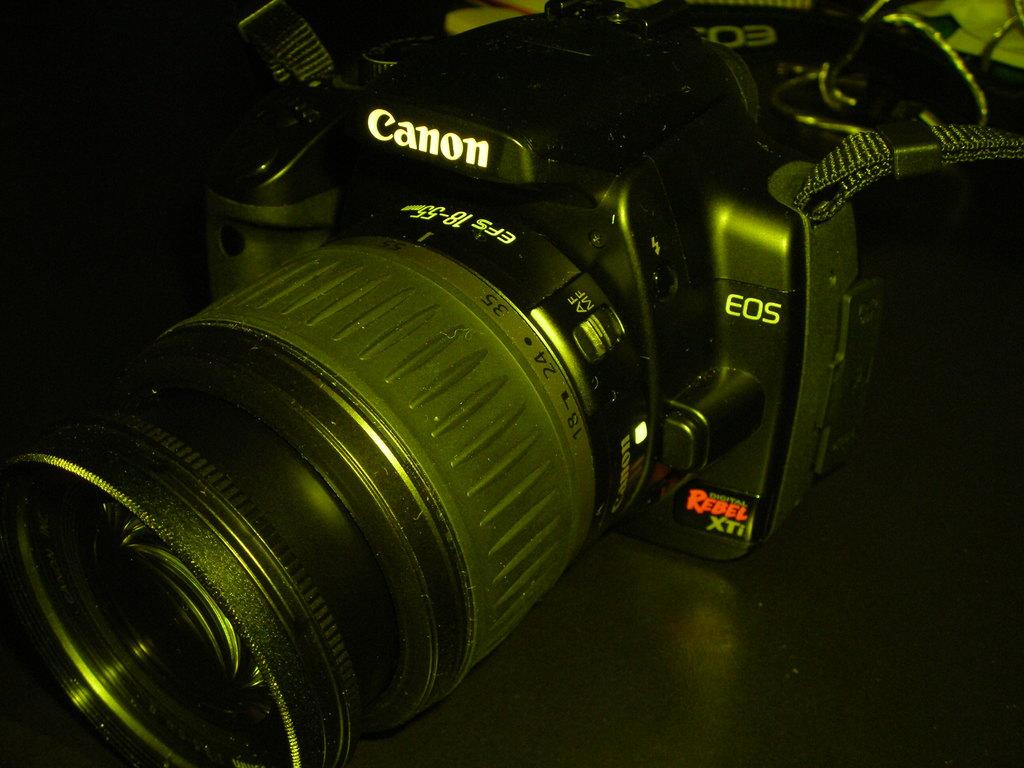What object is the main subject of the picture? The main subject of the picture is a camera. What is the color of the camera? The camera is black in color. What brand is the camera? The camera has "Canon" written on it, indicating that it is a Canon camera. How many ants are crawling on the camera in the image? There are no ants present in the image; the camera is the main subject. What type of adjustment can be made to the camera in the image? The image does not show any specific adjustments being made to the camera, so it cannot be determined from the image. 